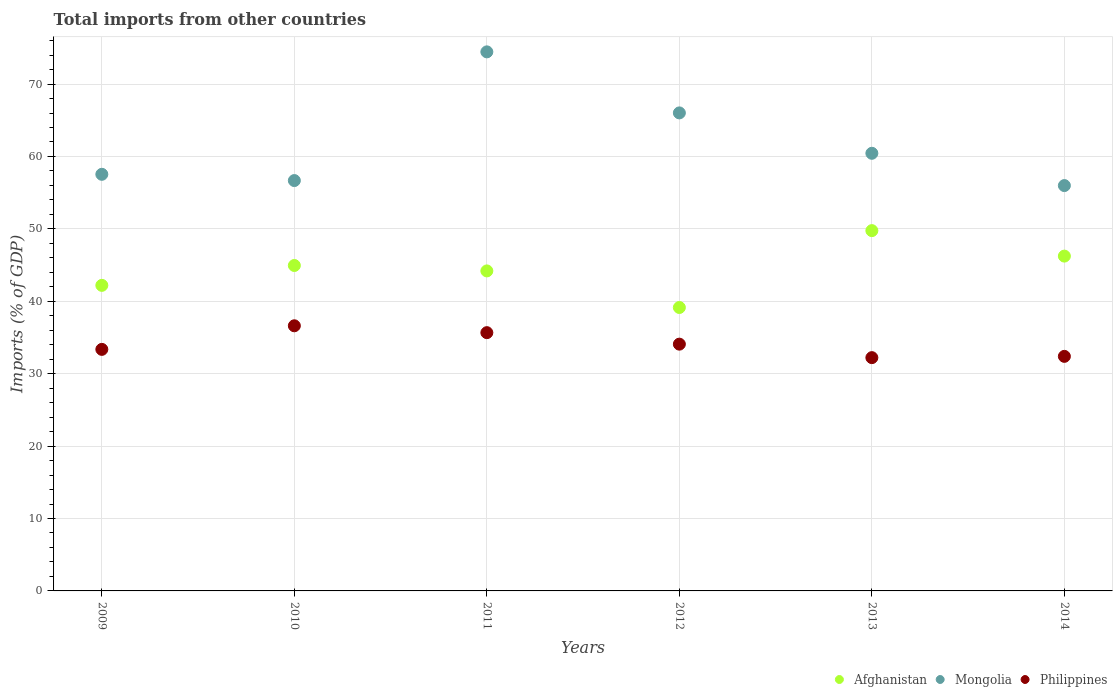Is the number of dotlines equal to the number of legend labels?
Your response must be concise. Yes. What is the total imports in Philippines in 2014?
Offer a terse response. 32.39. Across all years, what is the maximum total imports in Afghanistan?
Provide a succinct answer. 49.76. Across all years, what is the minimum total imports in Mongolia?
Your response must be concise. 55.98. In which year was the total imports in Philippines maximum?
Make the answer very short. 2010. In which year was the total imports in Mongolia minimum?
Offer a terse response. 2014. What is the total total imports in Mongolia in the graph?
Provide a succinct answer. 371.09. What is the difference between the total imports in Philippines in 2010 and that in 2011?
Make the answer very short. 0.95. What is the difference between the total imports in Mongolia in 2012 and the total imports in Afghanistan in 2009?
Make the answer very short. 23.82. What is the average total imports in Philippines per year?
Provide a succinct answer. 34.06. In the year 2011, what is the difference between the total imports in Philippines and total imports in Mongolia?
Make the answer very short. -38.78. What is the ratio of the total imports in Mongolia in 2011 to that in 2014?
Your response must be concise. 1.33. Is the total imports in Mongolia in 2012 less than that in 2014?
Keep it short and to the point. No. What is the difference between the highest and the second highest total imports in Mongolia?
Make the answer very short. 8.43. What is the difference between the highest and the lowest total imports in Mongolia?
Provide a succinct answer. 18.47. Does the total imports in Mongolia monotonically increase over the years?
Make the answer very short. No. Is the total imports in Philippines strictly less than the total imports in Mongolia over the years?
Offer a very short reply. Yes. How many years are there in the graph?
Provide a succinct answer. 6. Are the values on the major ticks of Y-axis written in scientific E-notation?
Your answer should be very brief. No. Does the graph contain grids?
Provide a short and direct response. Yes. Where does the legend appear in the graph?
Offer a terse response. Bottom right. How are the legend labels stacked?
Your answer should be compact. Horizontal. What is the title of the graph?
Make the answer very short. Total imports from other countries. Does "Cameroon" appear as one of the legend labels in the graph?
Your answer should be very brief. No. What is the label or title of the X-axis?
Your answer should be compact. Years. What is the label or title of the Y-axis?
Your answer should be compact. Imports (% of GDP). What is the Imports (% of GDP) of Afghanistan in 2009?
Your response must be concise. 42.2. What is the Imports (% of GDP) in Mongolia in 2009?
Provide a succinct answer. 57.54. What is the Imports (% of GDP) in Philippines in 2009?
Make the answer very short. 33.36. What is the Imports (% of GDP) in Afghanistan in 2010?
Give a very brief answer. 44.94. What is the Imports (% of GDP) in Mongolia in 2010?
Provide a succinct answer. 56.67. What is the Imports (% of GDP) of Philippines in 2010?
Provide a succinct answer. 36.62. What is the Imports (% of GDP) in Afghanistan in 2011?
Provide a short and direct response. 44.19. What is the Imports (% of GDP) in Mongolia in 2011?
Your answer should be very brief. 74.45. What is the Imports (% of GDP) of Philippines in 2011?
Make the answer very short. 35.67. What is the Imports (% of GDP) in Afghanistan in 2012?
Your answer should be very brief. 39.14. What is the Imports (% of GDP) in Mongolia in 2012?
Offer a very short reply. 66.02. What is the Imports (% of GDP) of Philippines in 2012?
Provide a succinct answer. 34.08. What is the Imports (% of GDP) in Afghanistan in 2013?
Keep it short and to the point. 49.76. What is the Imports (% of GDP) of Mongolia in 2013?
Give a very brief answer. 60.44. What is the Imports (% of GDP) of Philippines in 2013?
Offer a terse response. 32.22. What is the Imports (% of GDP) in Afghanistan in 2014?
Your response must be concise. 46.24. What is the Imports (% of GDP) of Mongolia in 2014?
Offer a terse response. 55.98. What is the Imports (% of GDP) in Philippines in 2014?
Provide a short and direct response. 32.39. Across all years, what is the maximum Imports (% of GDP) in Afghanistan?
Provide a succinct answer. 49.76. Across all years, what is the maximum Imports (% of GDP) in Mongolia?
Make the answer very short. 74.45. Across all years, what is the maximum Imports (% of GDP) in Philippines?
Give a very brief answer. 36.62. Across all years, what is the minimum Imports (% of GDP) of Afghanistan?
Provide a short and direct response. 39.14. Across all years, what is the minimum Imports (% of GDP) in Mongolia?
Keep it short and to the point. 55.98. Across all years, what is the minimum Imports (% of GDP) of Philippines?
Your answer should be compact. 32.22. What is the total Imports (% of GDP) in Afghanistan in the graph?
Offer a terse response. 266.48. What is the total Imports (% of GDP) in Mongolia in the graph?
Give a very brief answer. 371.09. What is the total Imports (% of GDP) in Philippines in the graph?
Your response must be concise. 204.33. What is the difference between the Imports (% of GDP) of Afghanistan in 2009 and that in 2010?
Offer a terse response. -2.74. What is the difference between the Imports (% of GDP) in Mongolia in 2009 and that in 2010?
Offer a very short reply. 0.86. What is the difference between the Imports (% of GDP) in Philippines in 2009 and that in 2010?
Provide a succinct answer. -3.26. What is the difference between the Imports (% of GDP) of Afghanistan in 2009 and that in 2011?
Offer a terse response. -1.99. What is the difference between the Imports (% of GDP) of Mongolia in 2009 and that in 2011?
Offer a terse response. -16.91. What is the difference between the Imports (% of GDP) in Philippines in 2009 and that in 2011?
Offer a terse response. -2.31. What is the difference between the Imports (% of GDP) in Afghanistan in 2009 and that in 2012?
Make the answer very short. 3.06. What is the difference between the Imports (% of GDP) in Mongolia in 2009 and that in 2012?
Provide a succinct answer. -8.48. What is the difference between the Imports (% of GDP) in Philippines in 2009 and that in 2012?
Provide a short and direct response. -0.72. What is the difference between the Imports (% of GDP) of Afghanistan in 2009 and that in 2013?
Provide a short and direct response. -7.56. What is the difference between the Imports (% of GDP) in Mongolia in 2009 and that in 2013?
Your answer should be very brief. -2.9. What is the difference between the Imports (% of GDP) of Philippines in 2009 and that in 2013?
Provide a short and direct response. 1.14. What is the difference between the Imports (% of GDP) of Afghanistan in 2009 and that in 2014?
Give a very brief answer. -4.04. What is the difference between the Imports (% of GDP) of Mongolia in 2009 and that in 2014?
Offer a terse response. 1.56. What is the difference between the Imports (% of GDP) of Philippines in 2009 and that in 2014?
Offer a terse response. 0.96. What is the difference between the Imports (% of GDP) of Afghanistan in 2010 and that in 2011?
Your response must be concise. 0.75. What is the difference between the Imports (% of GDP) of Mongolia in 2010 and that in 2011?
Keep it short and to the point. -17.77. What is the difference between the Imports (% of GDP) in Philippines in 2010 and that in 2011?
Provide a succinct answer. 0.95. What is the difference between the Imports (% of GDP) of Afghanistan in 2010 and that in 2012?
Make the answer very short. 5.8. What is the difference between the Imports (% of GDP) in Mongolia in 2010 and that in 2012?
Ensure brevity in your answer.  -9.35. What is the difference between the Imports (% of GDP) in Philippines in 2010 and that in 2012?
Give a very brief answer. 2.54. What is the difference between the Imports (% of GDP) of Afghanistan in 2010 and that in 2013?
Make the answer very short. -4.81. What is the difference between the Imports (% of GDP) of Mongolia in 2010 and that in 2013?
Your response must be concise. -3.77. What is the difference between the Imports (% of GDP) in Philippines in 2010 and that in 2013?
Keep it short and to the point. 4.4. What is the difference between the Imports (% of GDP) in Afghanistan in 2010 and that in 2014?
Provide a short and direct response. -1.3. What is the difference between the Imports (% of GDP) in Mongolia in 2010 and that in 2014?
Provide a succinct answer. 0.69. What is the difference between the Imports (% of GDP) of Philippines in 2010 and that in 2014?
Ensure brevity in your answer.  4.22. What is the difference between the Imports (% of GDP) in Afghanistan in 2011 and that in 2012?
Offer a very short reply. 5.05. What is the difference between the Imports (% of GDP) in Mongolia in 2011 and that in 2012?
Offer a terse response. 8.43. What is the difference between the Imports (% of GDP) of Philippines in 2011 and that in 2012?
Give a very brief answer. 1.59. What is the difference between the Imports (% of GDP) of Afghanistan in 2011 and that in 2013?
Offer a terse response. -5.56. What is the difference between the Imports (% of GDP) in Mongolia in 2011 and that in 2013?
Your response must be concise. 14.01. What is the difference between the Imports (% of GDP) of Philippines in 2011 and that in 2013?
Offer a very short reply. 3.45. What is the difference between the Imports (% of GDP) of Afghanistan in 2011 and that in 2014?
Provide a succinct answer. -2.05. What is the difference between the Imports (% of GDP) of Mongolia in 2011 and that in 2014?
Offer a terse response. 18.47. What is the difference between the Imports (% of GDP) of Philippines in 2011 and that in 2014?
Provide a short and direct response. 3.27. What is the difference between the Imports (% of GDP) of Afghanistan in 2012 and that in 2013?
Your response must be concise. -10.62. What is the difference between the Imports (% of GDP) of Mongolia in 2012 and that in 2013?
Your answer should be very brief. 5.58. What is the difference between the Imports (% of GDP) in Philippines in 2012 and that in 2013?
Offer a terse response. 1.86. What is the difference between the Imports (% of GDP) of Afghanistan in 2012 and that in 2014?
Your response must be concise. -7.1. What is the difference between the Imports (% of GDP) in Mongolia in 2012 and that in 2014?
Provide a succinct answer. 10.04. What is the difference between the Imports (% of GDP) in Philippines in 2012 and that in 2014?
Your answer should be compact. 1.69. What is the difference between the Imports (% of GDP) in Afghanistan in 2013 and that in 2014?
Give a very brief answer. 3.52. What is the difference between the Imports (% of GDP) in Mongolia in 2013 and that in 2014?
Offer a terse response. 4.46. What is the difference between the Imports (% of GDP) of Philippines in 2013 and that in 2014?
Ensure brevity in your answer.  -0.18. What is the difference between the Imports (% of GDP) of Afghanistan in 2009 and the Imports (% of GDP) of Mongolia in 2010?
Offer a terse response. -14.47. What is the difference between the Imports (% of GDP) in Afghanistan in 2009 and the Imports (% of GDP) in Philippines in 2010?
Your response must be concise. 5.58. What is the difference between the Imports (% of GDP) of Mongolia in 2009 and the Imports (% of GDP) of Philippines in 2010?
Your response must be concise. 20.92. What is the difference between the Imports (% of GDP) in Afghanistan in 2009 and the Imports (% of GDP) in Mongolia in 2011?
Keep it short and to the point. -32.25. What is the difference between the Imports (% of GDP) of Afghanistan in 2009 and the Imports (% of GDP) of Philippines in 2011?
Your answer should be very brief. 6.53. What is the difference between the Imports (% of GDP) of Mongolia in 2009 and the Imports (% of GDP) of Philippines in 2011?
Make the answer very short. 21.87. What is the difference between the Imports (% of GDP) in Afghanistan in 2009 and the Imports (% of GDP) in Mongolia in 2012?
Ensure brevity in your answer.  -23.82. What is the difference between the Imports (% of GDP) in Afghanistan in 2009 and the Imports (% of GDP) in Philippines in 2012?
Your answer should be compact. 8.12. What is the difference between the Imports (% of GDP) in Mongolia in 2009 and the Imports (% of GDP) in Philippines in 2012?
Your answer should be compact. 23.46. What is the difference between the Imports (% of GDP) in Afghanistan in 2009 and the Imports (% of GDP) in Mongolia in 2013?
Your answer should be compact. -18.24. What is the difference between the Imports (% of GDP) of Afghanistan in 2009 and the Imports (% of GDP) of Philippines in 2013?
Offer a very short reply. 9.98. What is the difference between the Imports (% of GDP) of Mongolia in 2009 and the Imports (% of GDP) of Philippines in 2013?
Offer a very short reply. 25.32. What is the difference between the Imports (% of GDP) in Afghanistan in 2009 and the Imports (% of GDP) in Mongolia in 2014?
Ensure brevity in your answer.  -13.78. What is the difference between the Imports (% of GDP) of Afghanistan in 2009 and the Imports (% of GDP) of Philippines in 2014?
Your answer should be very brief. 9.81. What is the difference between the Imports (% of GDP) in Mongolia in 2009 and the Imports (% of GDP) in Philippines in 2014?
Give a very brief answer. 25.14. What is the difference between the Imports (% of GDP) of Afghanistan in 2010 and the Imports (% of GDP) of Mongolia in 2011?
Offer a terse response. -29.5. What is the difference between the Imports (% of GDP) in Afghanistan in 2010 and the Imports (% of GDP) in Philippines in 2011?
Give a very brief answer. 9.28. What is the difference between the Imports (% of GDP) in Mongolia in 2010 and the Imports (% of GDP) in Philippines in 2011?
Provide a short and direct response. 21. What is the difference between the Imports (% of GDP) of Afghanistan in 2010 and the Imports (% of GDP) of Mongolia in 2012?
Keep it short and to the point. -21.07. What is the difference between the Imports (% of GDP) in Afghanistan in 2010 and the Imports (% of GDP) in Philippines in 2012?
Your answer should be compact. 10.86. What is the difference between the Imports (% of GDP) of Mongolia in 2010 and the Imports (% of GDP) of Philippines in 2012?
Make the answer very short. 22.59. What is the difference between the Imports (% of GDP) of Afghanistan in 2010 and the Imports (% of GDP) of Mongolia in 2013?
Provide a succinct answer. -15.49. What is the difference between the Imports (% of GDP) of Afghanistan in 2010 and the Imports (% of GDP) of Philippines in 2013?
Provide a succinct answer. 12.73. What is the difference between the Imports (% of GDP) in Mongolia in 2010 and the Imports (% of GDP) in Philippines in 2013?
Your answer should be very brief. 24.45. What is the difference between the Imports (% of GDP) in Afghanistan in 2010 and the Imports (% of GDP) in Mongolia in 2014?
Offer a very short reply. -11.04. What is the difference between the Imports (% of GDP) of Afghanistan in 2010 and the Imports (% of GDP) of Philippines in 2014?
Offer a terse response. 12.55. What is the difference between the Imports (% of GDP) of Mongolia in 2010 and the Imports (% of GDP) of Philippines in 2014?
Ensure brevity in your answer.  24.28. What is the difference between the Imports (% of GDP) of Afghanistan in 2011 and the Imports (% of GDP) of Mongolia in 2012?
Your response must be concise. -21.82. What is the difference between the Imports (% of GDP) of Afghanistan in 2011 and the Imports (% of GDP) of Philippines in 2012?
Provide a succinct answer. 10.11. What is the difference between the Imports (% of GDP) in Mongolia in 2011 and the Imports (% of GDP) in Philippines in 2012?
Make the answer very short. 40.37. What is the difference between the Imports (% of GDP) in Afghanistan in 2011 and the Imports (% of GDP) in Mongolia in 2013?
Give a very brief answer. -16.24. What is the difference between the Imports (% of GDP) in Afghanistan in 2011 and the Imports (% of GDP) in Philippines in 2013?
Your response must be concise. 11.98. What is the difference between the Imports (% of GDP) of Mongolia in 2011 and the Imports (% of GDP) of Philippines in 2013?
Ensure brevity in your answer.  42.23. What is the difference between the Imports (% of GDP) in Afghanistan in 2011 and the Imports (% of GDP) in Mongolia in 2014?
Your answer should be compact. -11.79. What is the difference between the Imports (% of GDP) in Afghanistan in 2011 and the Imports (% of GDP) in Philippines in 2014?
Keep it short and to the point. 11.8. What is the difference between the Imports (% of GDP) in Mongolia in 2011 and the Imports (% of GDP) in Philippines in 2014?
Offer a terse response. 42.05. What is the difference between the Imports (% of GDP) of Afghanistan in 2012 and the Imports (% of GDP) of Mongolia in 2013?
Provide a succinct answer. -21.3. What is the difference between the Imports (% of GDP) in Afghanistan in 2012 and the Imports (% of GDP) in Philippines in 2013?
Offer a terse response. 6.93. What is the difference between the Imports (% of GDP) of Mongolia in 2012 and the Imports (% of GDP) of Philippines in 2013?
Your answer should be very brief. 33.8. What is the difference between the Imports (% of GDP) of Afghanistan in 2012 and the Imports (% of GDP) of Mongolia in 2014?
Your answer should be very brief. -16.84. What is the difference between the Imports (% of GDP) in Afghanistan in 2012 and the Imports (% of GDP) in Philippines in 2014?
Provide a succinct answer. 6.75. What is the difference between the Imports (% of GDP) in Mongolia in 2012 and the Imports (% of GDP) in Philippines in 2014?
Provide a succinct answer. 33.62. What is the difference between the Imports (% of GDP) in Afghanistan in 2013 and the Imports (% of GDP) in Mongolia in 2014?
Provide a short and direct response. -6.22. What is the difference between the Imports (% of GDP) in Afghanistan in 2013 and the Imports (% of GDP) in Philippines in 2014?
Your answer should be very brief. 17.36. What is the difference between the Imports (% of GDP) in Mongolia in 2013 and the Imports (% of GDP) in Philippines in 2014?
Offer a terse response. 28.04. What is the average Imports (% of GDP) in Afghanistan per year?
Make the answer very short. 44.41. What is the average Imports (% of GDP) in Mongolia per year?
Offer a terse response. 61.85. What is the average Imports (% of GDP) in Philippines per year?
Provide a short and direct response. 34.06. In the year 2009, what is the difference between the Imports (% of GDP) of Afghanistan and Imports (% of GDP) of Mongolia?
Ensure brevity in your answer.  -15.34. In the year 2009, what is the difference between the Imports (% of GDP) of Afghanistan and Imports (% of GDP) of Philippines?
Offer a terse response. 8.84. In the year 2009, what is the difference between the Imports (% of GDP) of Mongolia and Imports (% of GDP) of Philippines?
Give a very brief answer. 24.18. In the year 2010, what is the difference between the Imports (% of GDP) in Afghanistan and Imports (% of GDP) in Mongolia?
Keep it short and to the point. -11.73. In the year 2010, what is the difference between the Imports (% of GDP) in Afghanistan and Imports (% of GDP) in Philippines?
Your answer should be very brief. 8.33. In the year 2010, what is the difference between the Imports (% of GDP) in Mongolia and Imports (% of GDP) in Philippines?
Offer a very short reply. 20.05. In the year 2011, what is the difference between the Imports (% of GDP) of Afghanistan and Imports (% of GDP) of Mongolia?
Offer a very short reply. -30.25. In the year 2011, what is the difference between the Imports (% of GDP) of Afghanistan and Imports (% of GDP) of Philippines?
Offer a terse response. 8.53. In the year 2011, what is the difference between the Imports (% of GDP) of Mongolia and Imports (% of GDP) of Philippines?
Keep it short and to the point. 38.78. In the year 2012, what is the difference between the Imports (% of GDP) in Afghanistan and Imports (% of GDP) in Mongolia?
Keep it short and to the point. -26.87. In the year 2012, what is the difference between the Imports (% of GDP) in Afghanistan and Imports (% of GDP) in Philippines?
Ensure brevity in your answer.  5.06. In the year 2012, what is the difference between the Imports (% of GDP) in Mongolia and Imports (% of GDP) in Philippines?
Offer a terse response. 31.94. In the year 2013, what is the difference between the Imports (% of GDP) in Afghanistan and Imports (% of GDP) in Mongolia?
Make the answer very short. -10.68. In the year 2013, what is the difference between the Imports (% of GDP) in Afghanistan and Imports (% of GDP) in Philippines?
Offer a terse response. 17.54. In the year 2013, what is the difference between the Imports (% of GDP) of Mongolia and Imports (% of GDP) of Philippines?
Provide a succinct answer. 28.22. In the year 2014, what is the difference between the Imports (% of GDP) of Afghanistan and Imports (% of GDP) of Mongolia?
Offer a terse response. -9.74. In the year 2014, what is the difference between the Imports (% of GDP) in Afghanistan and Imports (% of GDP) in Philippines?
Offer a terse response. 13.85. In the year 2014, what is the difference between the Imports (% of GDP) in Mongolia and Imports (% of GDP) in Philippines?
Offer a terse response. 23.59. What is the ratio of the Imports (% of GDP) of Afghanistan in 2009 to that in 2010?
Your answer should be compact. 0.94. What is the ratio of the Imports (% of GDP) of Mongolia in 2009 to that in 2010?
Offer a terse response. 1.02. What is the ratio of the Imports (% of GDP) of Philippines in 2009 to that in 2010?
Your response must be concise. 0.91. What is the ratio of the Imports (% of GDP) in Afghanistan in 2009 to that in 2011?
Your answer should be very brief. 0.95. What is the ratio of the Imports (% of GDP) in Mongolia in 2009 to that in 2011?
Make the answer very short. 0.77. What is the ratio of the Imports (% of GDP) in Philippines in 2009 to that in 2011?
Provide a succinct answer. 0.94. What is the ratio of the Imports (% of GDP) in Afghanistan in 2009 to that in 2012?
Make the answer very short. 1.08. What is the ratio of the Imports (% of GDP) of Mongolia in 2009 to that in 2012?
Make the answer very short. 0.87. What is the ratio of the Imports (% of GDP) of Philippines in 2009 to that in 2012?
Keep it short and to the point. 0.98. What is the ratio of the Imports (% of GDP) in Afghanistan in 2009 to that in 2013?
Provide a short and direct response. 0.85. What is the ratio of the Imports (% of GDP) of Philippines in 2009 to that in 2013?
Offer a terse response. 1.04. What is the ratio of the Imports (% of GDP) of Afghanistan in 2009 to that in 2014?
Provide a short and direct response. 0.91. What is the ratio of the Imports (% of GDP) of Mongolia in 2009 to that in 2014?
Offer a terse response. 1.03. What is the ratio of the Imports (% of GDP) of Philippines in 2009 to that in 2014?
Provide a short and direct response. 1.03. What is the ratio of the Imports (% of GDP) in Mongolia in 2010 to that in 2011?
Offer a very short reply. 0.76. What is the ratio of the Imports (% of GDP) in Philippines in 2010 to that in 2011?
Provide a short and direct response. 1.03. What is the ratio of the Imports (% of GDP) in Afghanistan in 2010 to that in 2012?
Make the answer very short. 1.15. What is the ratio of the Imports (% of GDP) in Mongolia in 2010 to that in 2012?
Make the answer very short. 0.86. What is the ratio of the Imports (% of GDP) of Philippines in 2010 to that in 2012?
Your answer should be very brief. 1.07. What is the ratio of the Imports (% of GDP) in Afghanistan in 2010 to that in 2013?
Give a very brief answer. 0.9. What is the ratio of the Imports (% of GDP) in Mongolia in 2010 to that in 2013?
Provide a short and direct response. 0.94. What is the ratio of the Imports (% of GDP) of Philippines in 2010 to that in 2013?
Your response must be concise. 1.14. What is the ratio of the Imports (% of GDP) of Afghanistan in 2010 to that in 2014?
Provide a short and direct response. 0.97. What is the ratio of the Imports (% of GDP) of Mongolia in 2010 to that in 2014?
Provide a succinct answer. 1.01. What is the ratio of the Imports (% of GDP) of Philippines in 2010 to that in 2014?
Offer a very short reply. 1.13. What is the ratio of the Imports (% of GDP) in Afghanistan in 2011 to that in 2012?
Your response must be concise. 1.13. What is the ratio of the Imports (% of GDP) of Mongolia in 2011 to that in 2012?
Ensure brevity in your answer.  1.13. What is the ratio of the Imports (% of GDP) of Philippines in 2011 to that in 2012?
Your answer should be compact. 1.05. What is the ratio of the Imports (% of GDP) in Afghanistan in 2011 to that in 2013?
Your answer should be very brief. 0.89. What is the ratio of the Imports (% of GDP) in Mongolia in 2011 to that in 2013?
Make the answer very short. 1.23. What is the ratio of the Imports (% of GDP) of Philippines in 2011 to that in 2013?
Your answer should be very brief. 1.11. What is the ratio of the Imports (% of GDP) of Afghanistan in 2011 to that in 2014?
Provide a short and direct response. 0.96. What is the ratio of the Imports (% of GDP) in Mongolia in 2011 to that in 2014?
Give a very brief answer. 1.33. What is the ratio of the Imports (% of GDP) in Philippines in 2011 to that in 2014?
Make the answer very short. 1.1. What is the ratio of the Imports (% of GDP) of Afghanistan in 2012 to that in 2013?
Offer a very short reply. 0.79. What is the ratio of the Imports (% of GDP) in Mongolia in 2012 to that in 2013?
Your answer should be very brief. 1.09. What is the ratio of the Imports (% of GDP) of Philippines in 2012 to that in 2013?
Provide a short and direct response. 1.06. What is the ratio of the Imports (% of GDP) of Afghanistan in 2012 to that in 2014?
Make the answer very short. 0.85. What is the ratio of the Imports (% of GDP) in Mongolia in 2012 to that in 2014?
Offer a terse response. 1.18. What is the ratio of the Imports (% of GDP) in Philippines in 2012 to that in 2014?
Your answer should be compact. 1.05. What is the ratio of the Imports (% of GDP) of Afghanistan in 2013 to that in 2014?
Keep it short and to the point. 1.08. What is the ratio of the Imports (% of GDP) of Mongolia in 2013 to that in 2014?
Offer a terse response. 1.08. What is the difference between the highest and the second highest Imports (% of GDP) in Afghanistan?
Make the answer very short. 3.52. What is the difference between the highest and the second highest Imports (% of GDP) of Mongolia?
Provide a short and direct response. 8.43. What is the difference between the highest and the second highest Imports (% of GDP) of Philippines?
Give a very brief answer. 0.95. What is the difference between the highest and the lowest Imports (% of GDP) of Afghanistan?
Your answer should be very brief. 10.62. What is the difference between the highest and the lowest Imports (% of GDP) of Mongolia?
Give a very brief answer. 18.47. What is the difference between the highest and the lowest Imports (% of GDP) in Philippines?
Offer a terse response. 4.4. 